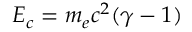Convert formula to latex. <formula><loc_0><loc_0><loc_500><loc_500>E _ { c } = m _ { e } c ^ { 2 } ( \gamma - 1 )</formula> 